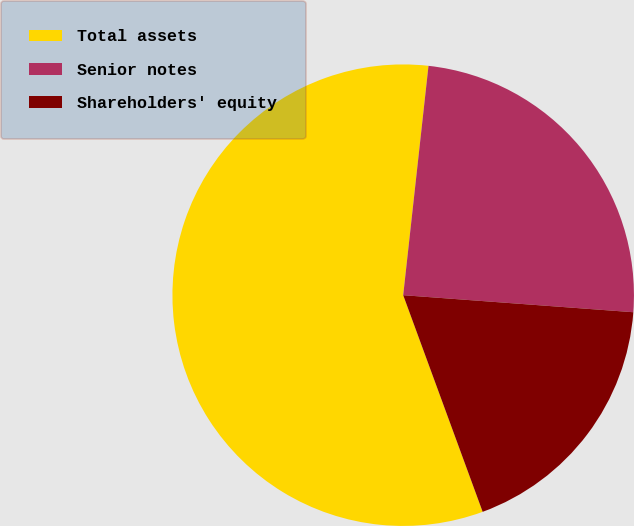<chart> <loc_0><loc_0><loc_500><loc_500><pie_chart><fcel>Total assets<fcel>Senior notes<fcel>Shareholders' equity<nl><fcel>57.35%<fcel>24.43%<fcel>18.23%<nl></chart> 